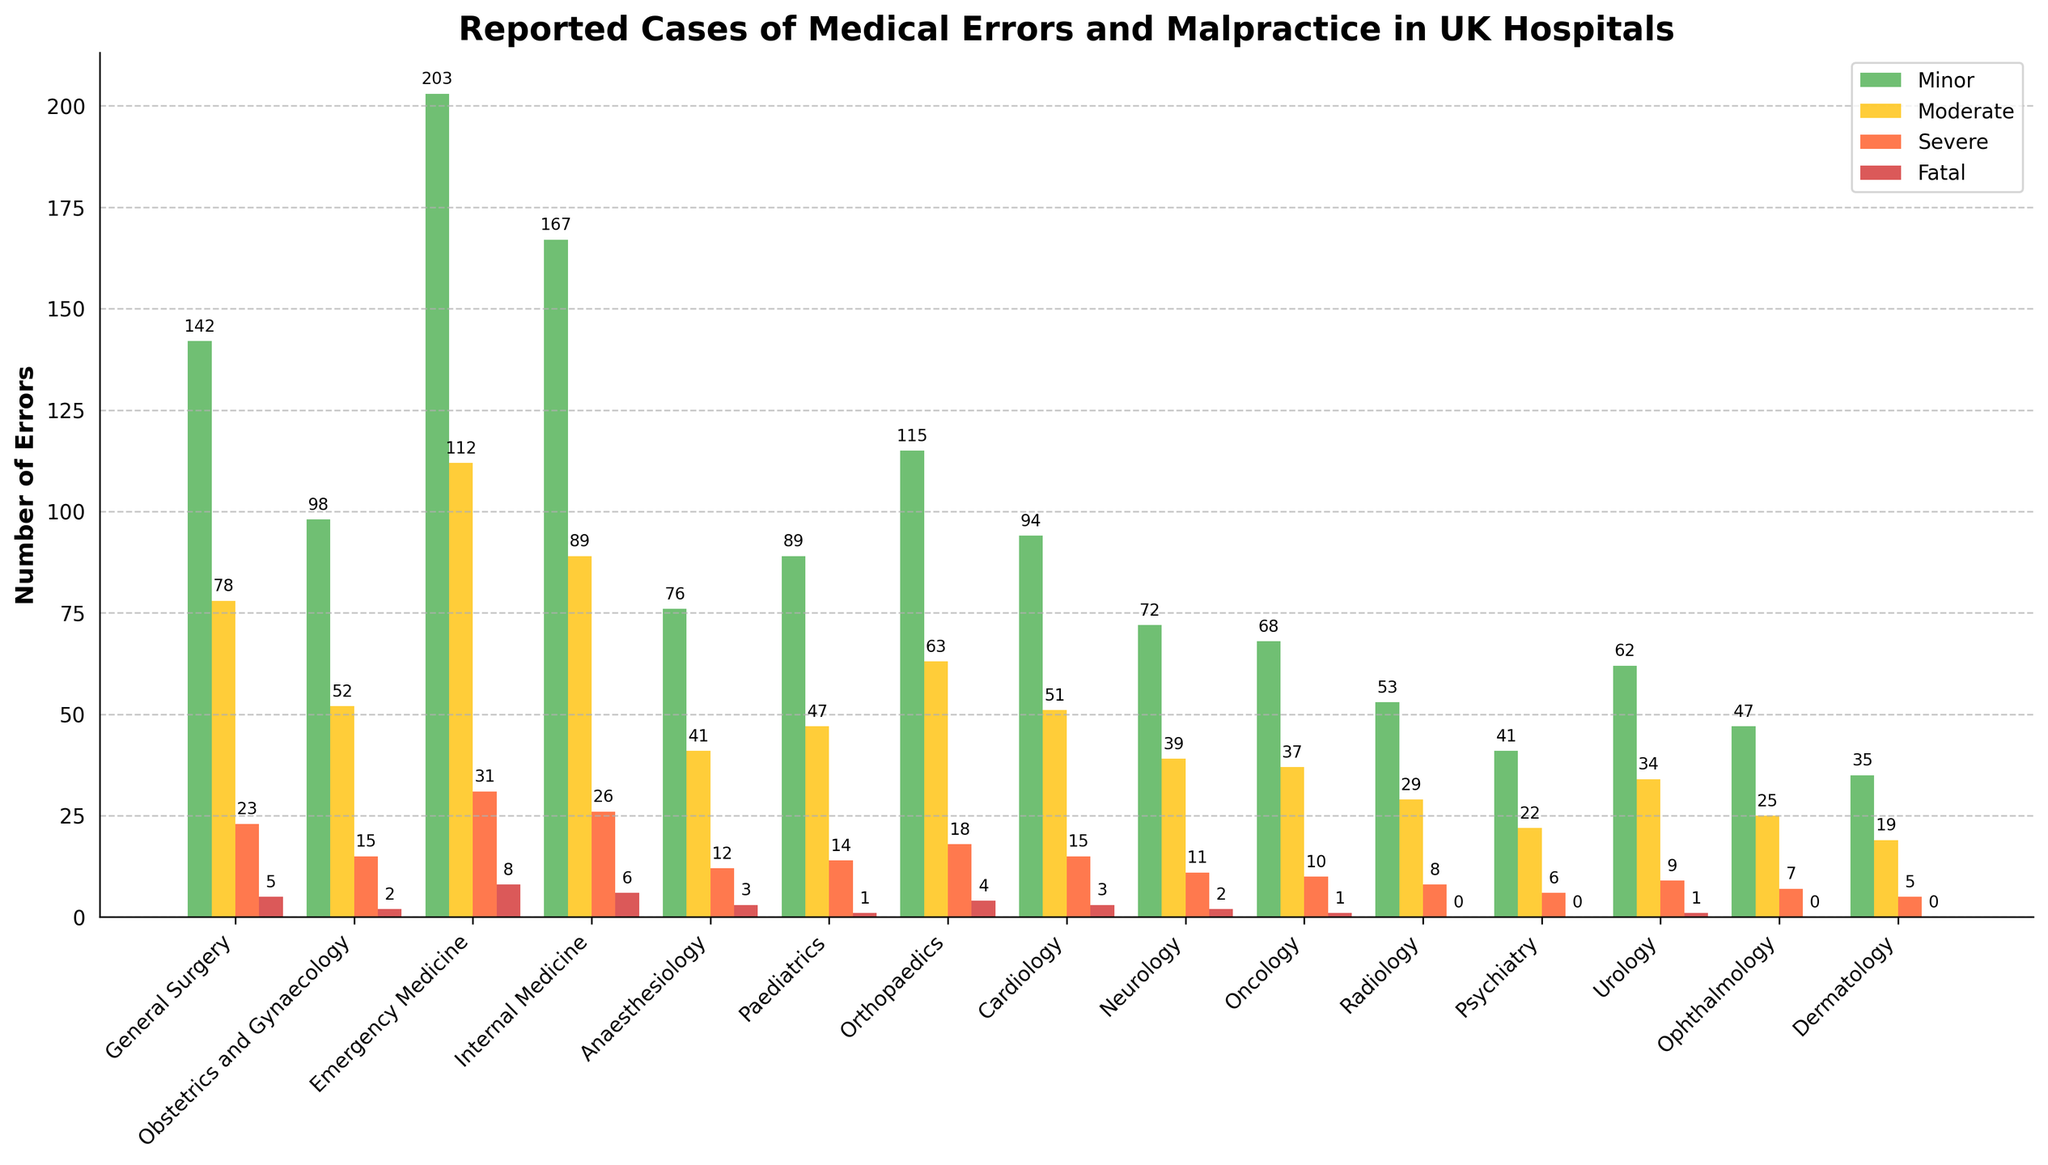What department has the highest number of minor errors reported? To determine which department reported the highest number of minor errors, examine the heights and labels of the green bars. The Emergency Medicine department has the tallest green bar with 203 errors.
Answer: Emergency Medicine Which department reports more moderate errors, Obstetrics and Gynaecology or Internal Medicine? To compare, refer to the yellow bars for these departments. Obstetrics and Gynaecology reports 52 moderate errors, while Internal Medicine reports 89 moderate errors.
Answer: Internal Medicine What is the total number of severe errors and fatal errors reported in the Cardiology department? Find the red and dark red bars' heights in the Cardiology department, which are 15 and 3 respectively. Sum them: 15 + 3 = 18.
Answer: 18 How many more minor errors are reported in General Surgery compared to Radiology? Find the green bars for General Surgery and Radiology; they report 142 and 53 errors, respectively. The difference is 142 - 53 = 89.
Answer: 89 Which department has the lowest number of total errors (sum of all error types) and what is that number? Sum all error categories for each department to find the totals. Dermatology reports the fewest errors with sums of 35 (minor) + 19 (moderate) + 5 (severe) + 0 (fatal) = 59 errors.
Answer: Dermatology; 59 How many more total errors are reported in Emergency Medicine than in Neurology? Calculate the total errors for each department. For Emergency Medicine: 203 + 112 + 31 + 8 = 354. For Neurology: 72 + 39 + 11 + 2 = 124. The difference: 354 - 124 = 230.
Answer: 230 What is the ratio of fatal errors between Paediatrics and Anaesthesiology? Look at the dark red bars for these departments: Paediatrics has 1 fatal error, and Anaesthesiology has 3. The ratio is 1:3.
Answer: 1:3 Which department shows the closest number of moderate and severe errors? Compare yellow and red bars for each department. Oncology has 37 moderate and 10 severe errors, which have the smallest difference (27).
Answer: Oncology What is the sum of minor errors reported in Obstetrics and Gynaecology and Paediatrics? Look at the green bars: Obstetrics and Gynaecology reports 98 minor errors and Paediatrics reports 89. The sum is 98 + 89 = 187.
Answer: 187 Which department reports no fatal errors? Check for departments with a dark red bar of zero height. Radiology, Psychiatry, Ophthalmology, and Dermatology report no fatal errors.
Answer: Radiology, Psychiatry, Ophthalmology, Dermatology 